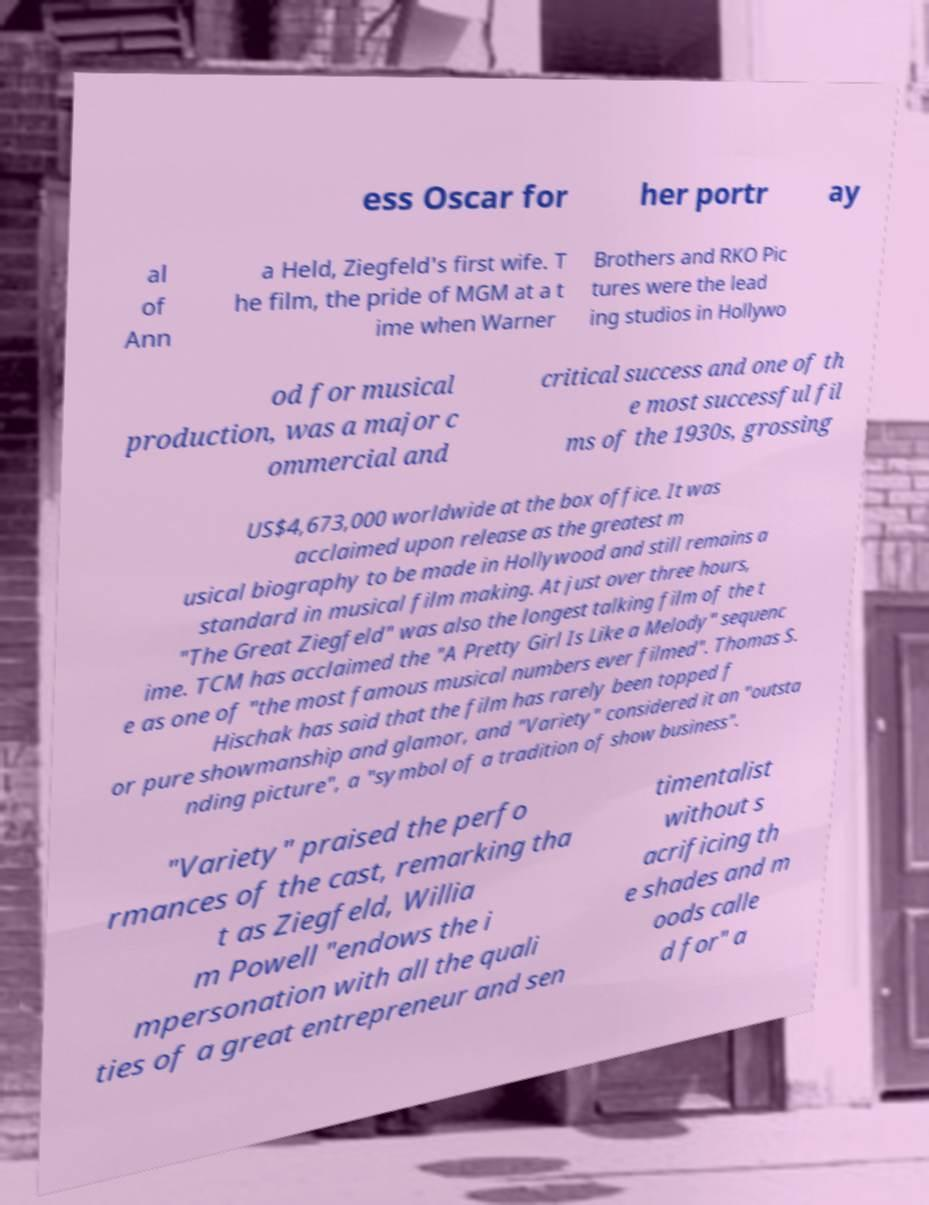Could you assist in decoding the text presented in this image and type it out clearly? ess Oscar for her portr ay al of Ann a Held, Ziegfeld's first wife. T he film, the pride of MGM at a t ime when Warner Brothers and RKO Pic tures were the lead ing studios in Hollywo od for musical production, was a major c ommercial and critical success and one of th e most successful fil ms of the 1930s, grossing US$4,673,000 worldwide at the box office. It was acclaimed upon release as the greatest m usical biography to be made in Hollywood and still remains a standard in musical film making. At just over three hours, "The Great Ziegfeld" was also the longest talking film of the t ime. TCM has acclaimed the "A Pretty Girl Is Like a Melody" sequenc e as one of "the most famous musical numbers ever filmed". Thomas S. Hischak has said that the film has rarely been topped f or pure showmanship and glamor, and "Variety" considered it an "outsta nding picture", a "symbol of a tradition of show business". "Variety" praised the perfo rmances of the cast, remarking tha t as Ziegfeld, Willia m Powell "endows the i mpersonation with all the quali ties of a great entrepreneur and sen timentalist without s acrificing th e shades and m oods calle d for" a 